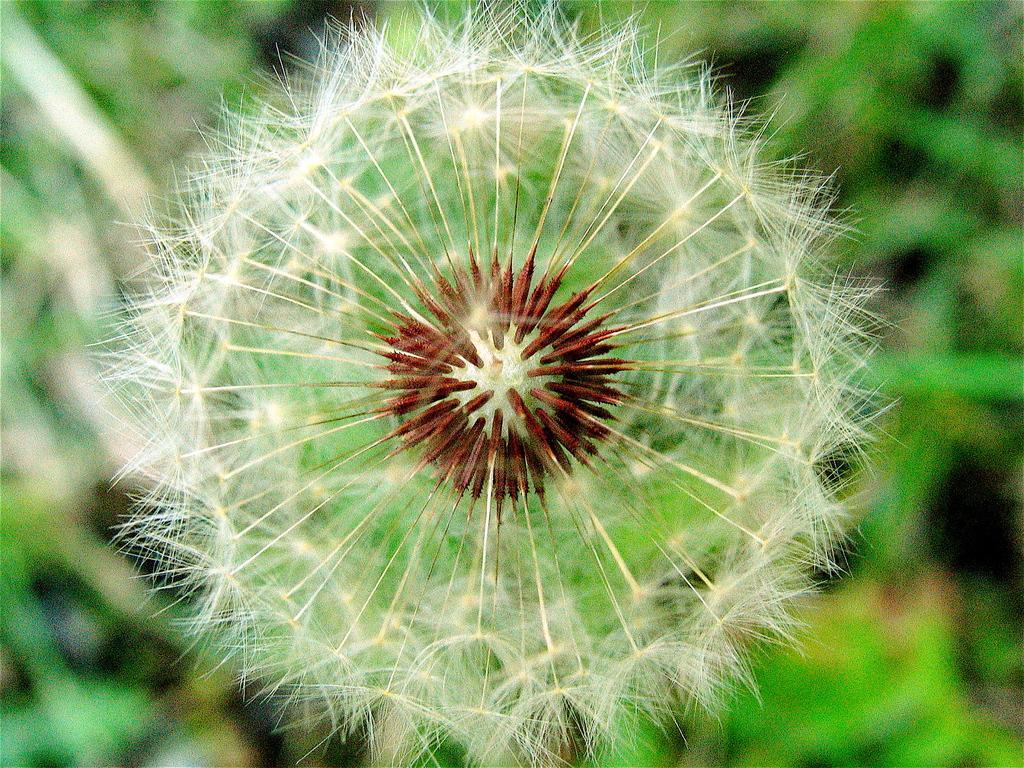Could you give a brief overview of what you see in this image? Here we can see a flower and there is a blur background with greenery. 